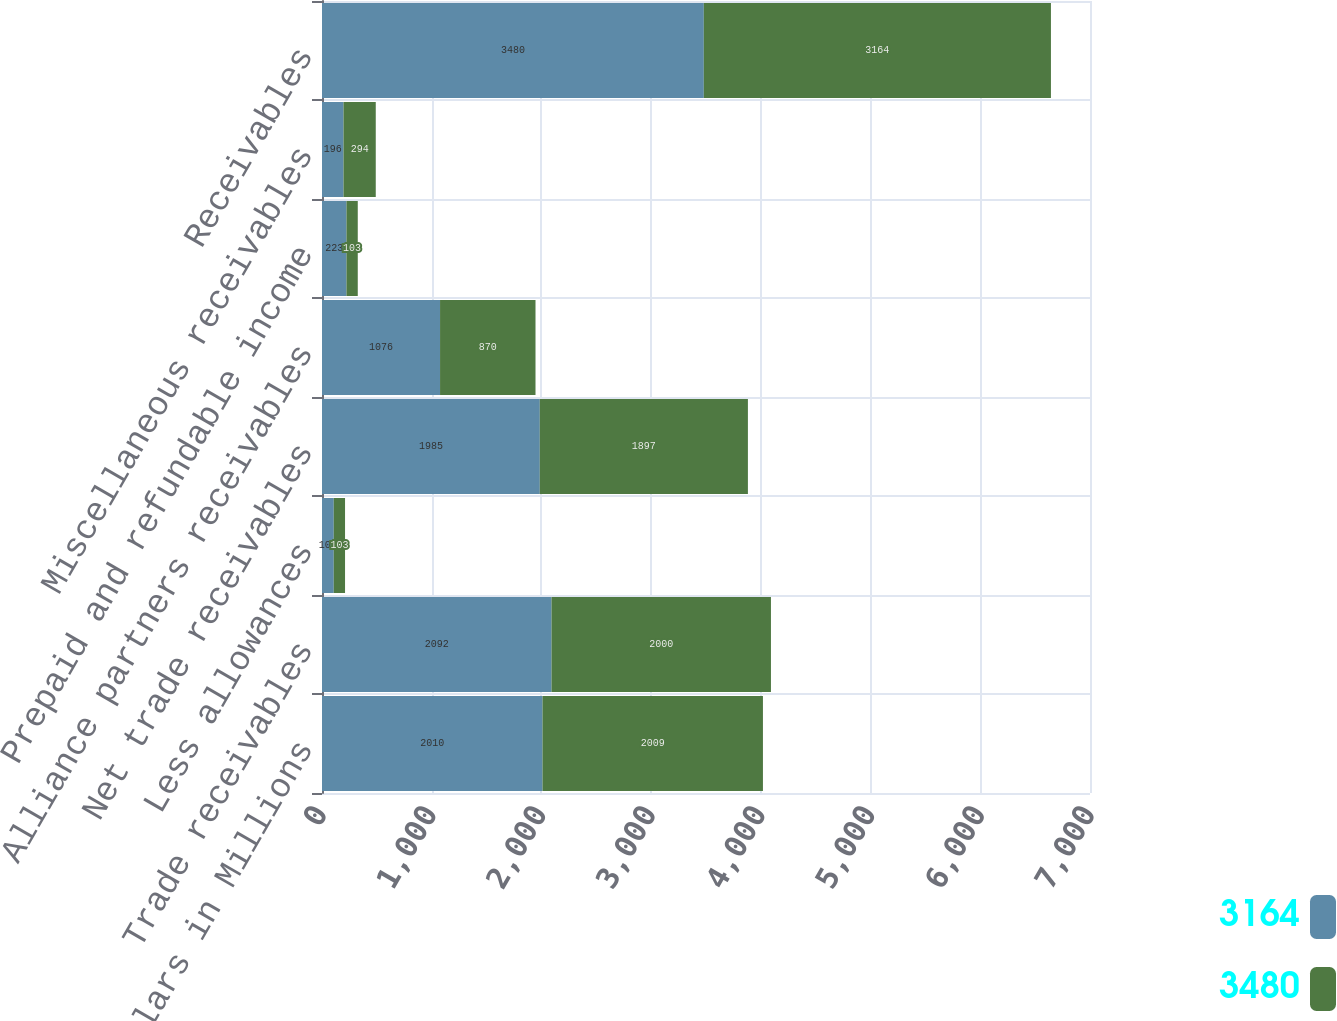Convert chart to OTSL. <chart><loc_0><loc_0><loc_500><loc_500><stacked_bar_chart><ecel><fcel>Dollars in Millions<fcel>Trade receivables<fcel>Less allowances<fcel>Net trade receivables<fcel>Alliance partners receivables<fcel>Prepaid and refundable income<fcel>Miscellaneous receivables<fcel>Receivables<nl><fcel>3164<fcel>2010<fcel>2092<fcel>107<fcel>1985<fcel>1076<fcel>223<fcel>196<fcel>3480<nl><fcel>3480<fcel>2009<fcel>2000<fcel>103<fcel>1897<fcel>870<fcel>103<fcel>294<fcel>3164<nl></chart> 